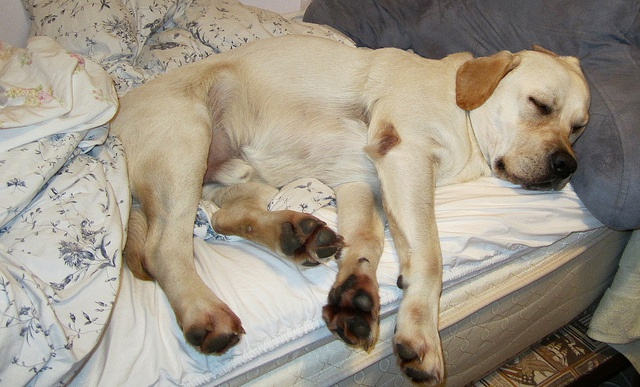Describe the objects in this image and their specific colors. I can see bed in darkgray, gray, and lightgray tones and dog in darkgray and tan tones in this image. 